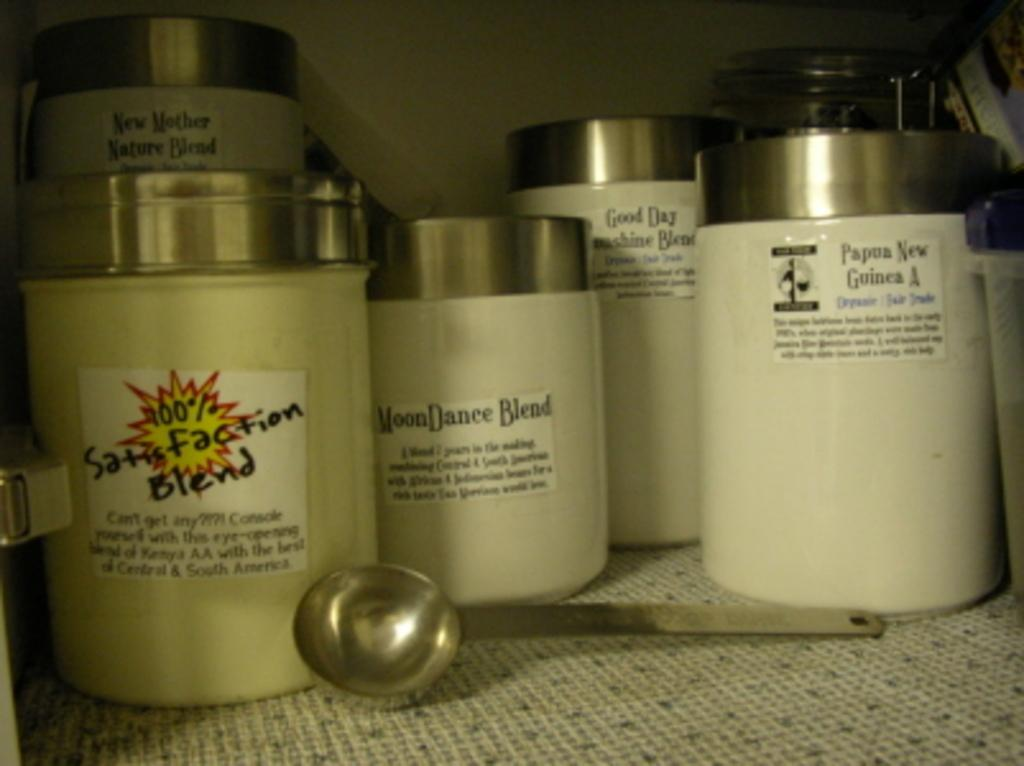Provide a one-sentence caption for the provided image. A white bottle that says Moon Dance Blend on it. 